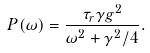Convert formula to latex. <formula><loc_0><loc_0><loc_500><loc_500>P ( \omega ) = \frac { \tau _ { r } \gamma g ^ { 2 } } { \omega ^ { 2 } + \gamma ^ { 2 } / 4 } .</formula> 